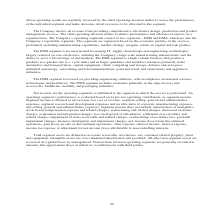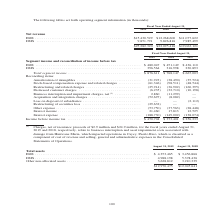According to Jabil Circuit's financial document, What was the Net revenue for EMS in 2019? According to the financial document, $15,430,529 (in thousands). The relevant text states: "Net revenue EMS . $15,430,529 $12,268,600 $11,077,622 DMS . 9,851,791 9,826,816 7,985,499..." Also, What was the DMS segment focused on? providing engineering solutions, with an emphasis on material sciences, technologies and healthcare.. The document states: "The DMS segment is focused on providing engineering solutions, with an emphasis on material sciences, technologies and healthcare. The DMS segment inc..." Also, What years does the table provide information for net revenue for EMS and DMS segments? The document contains multiple relevant values: 2019, 2018, 2017. From the document: "2019 2018 2017 2019 2018 2017 2019 2018 2017..." Also, How many years did net revenue from EMS exceed $15,000,000 thousand? Based on the analysis, there are 1 instances. The counting process: 2019. Also, can you calculate: What was the change in the net revenue from EMS between 2018 and 2019? Based on the calculation: 15,430,529-12,268,600, the result is 3161929 (in thousands). This is based on the information: "Net revenue EMS . $15,430,529 $12,268,600 $11,077,622 DMS . 9,851,791 9,826,816 7,985,499 Net revenue EMS . $15,430,529 $12,268,600 $11,077,622 DMS . 9,851,791 9,826,816 7,985,499..." The key data points involved are: 12,268,600, 15,430,529. Also, can you calculate: What was the average year-on-year percentage change in total net revenue from 2017-2019? To answer this question, I need to perform calculations using the financial data. The calculation is: ((($25,282,320-$22,095,416)/$22,095,416)+(($22,095,416-$19,063,121)/$19,063,121))/2, which equals 15.16 (percentage). This is based on the information: "$25,282,320 $22,095,416 $19,063,121 $25,282,320 $22,095,416 $19,063,121 $25,282,320 $22,095,416 $19,063,121 $25,282,320 $22,095,416 $19,063,121..." The key data points involved are: 19,063,121, 2, 22,095,416. 